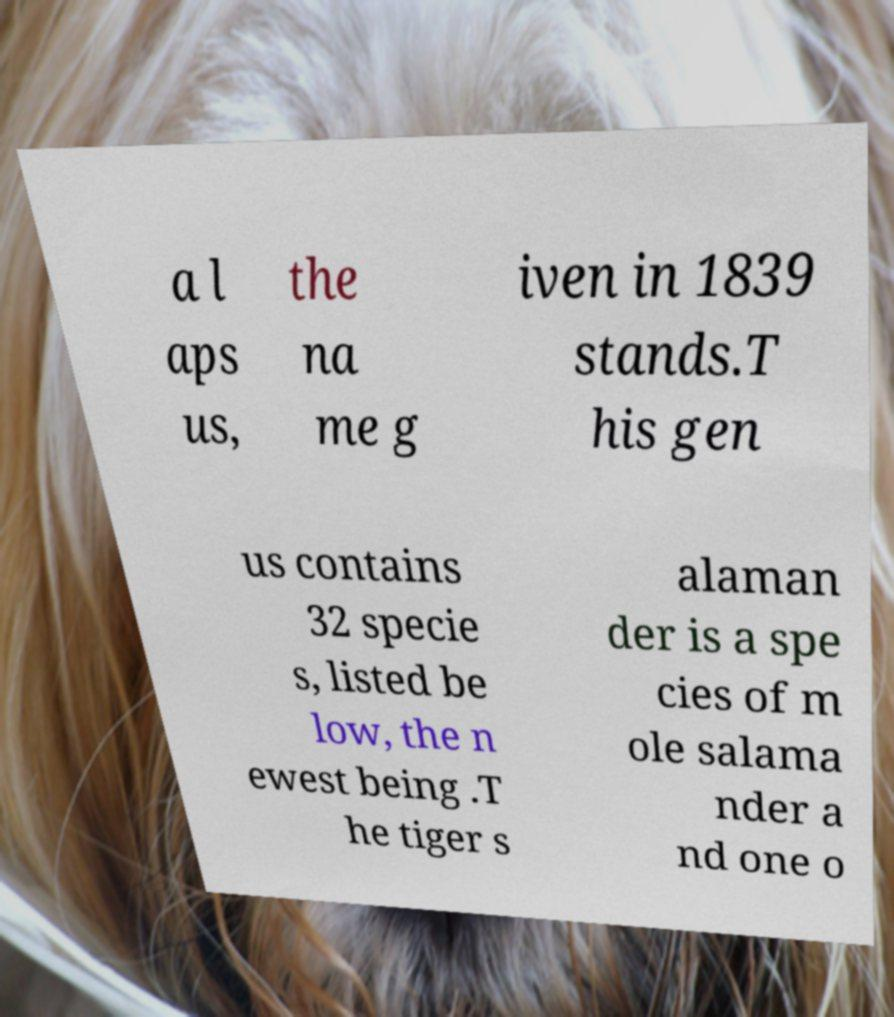I need the written content from this picture converted into text. Can you do that? a l aps us, the na me g iven in 1839 stands.T his gen us contains 32 specie s, listed be low, the n ewest being .T he tiger s alaman der is a spe cies of m ole salama nder a nd one o 